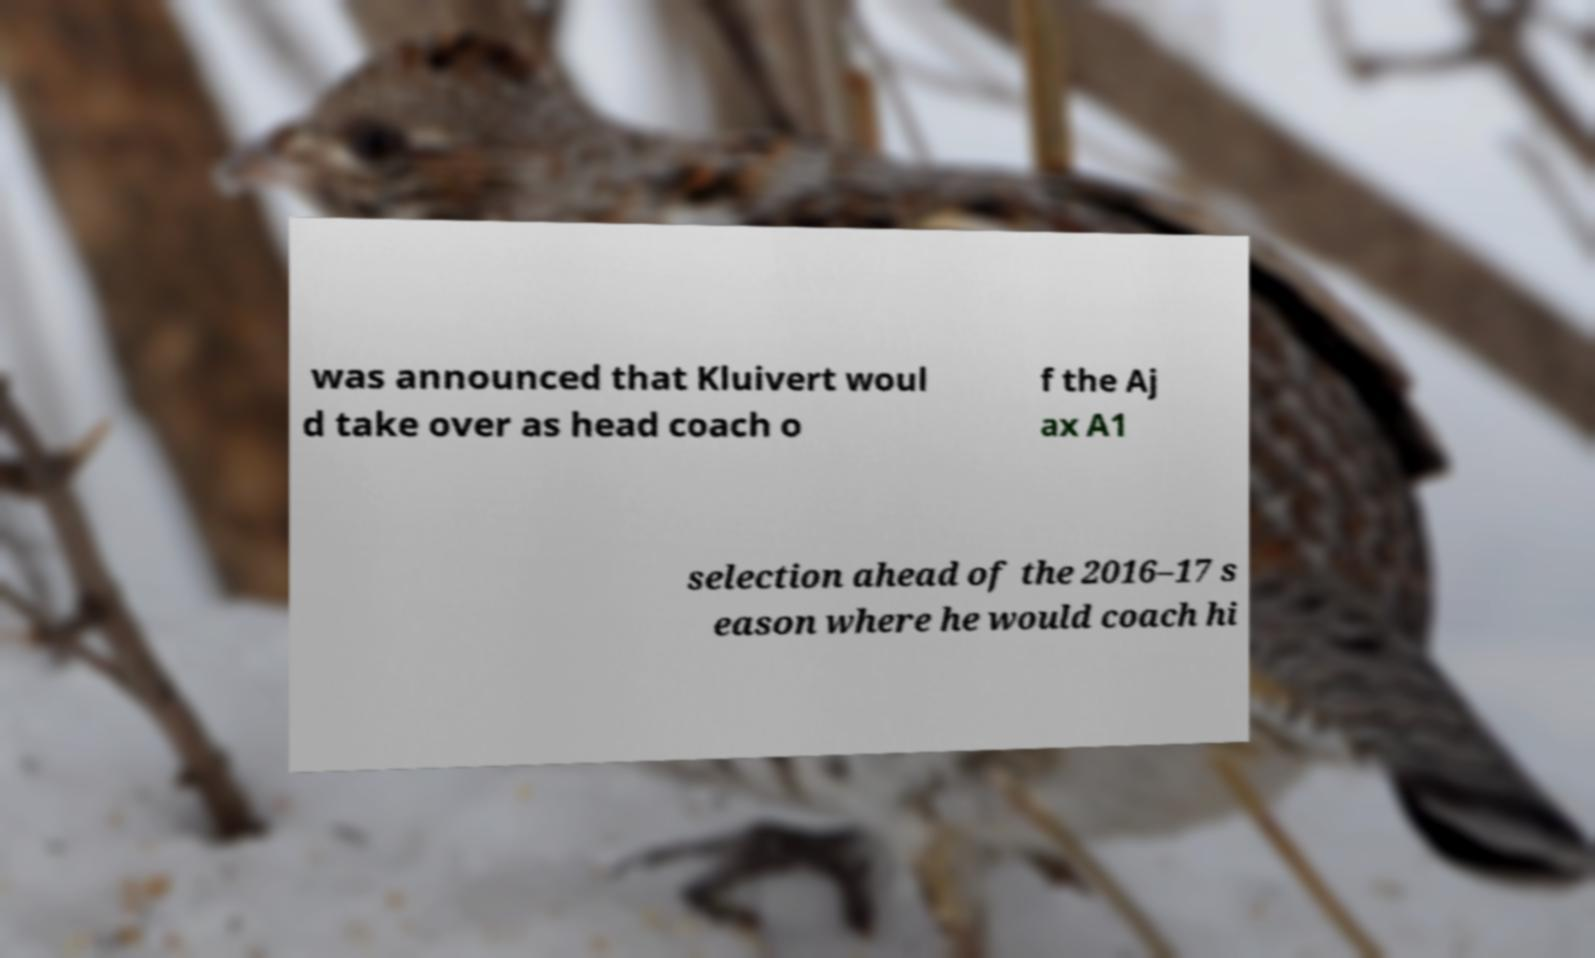I need the written content from this picture converted into text. Can you do that? was announced that Kluivert woul d take over as head coach o f the Aj ax A1 selection ahead of the 2016–17 s eason where he would coach hi 